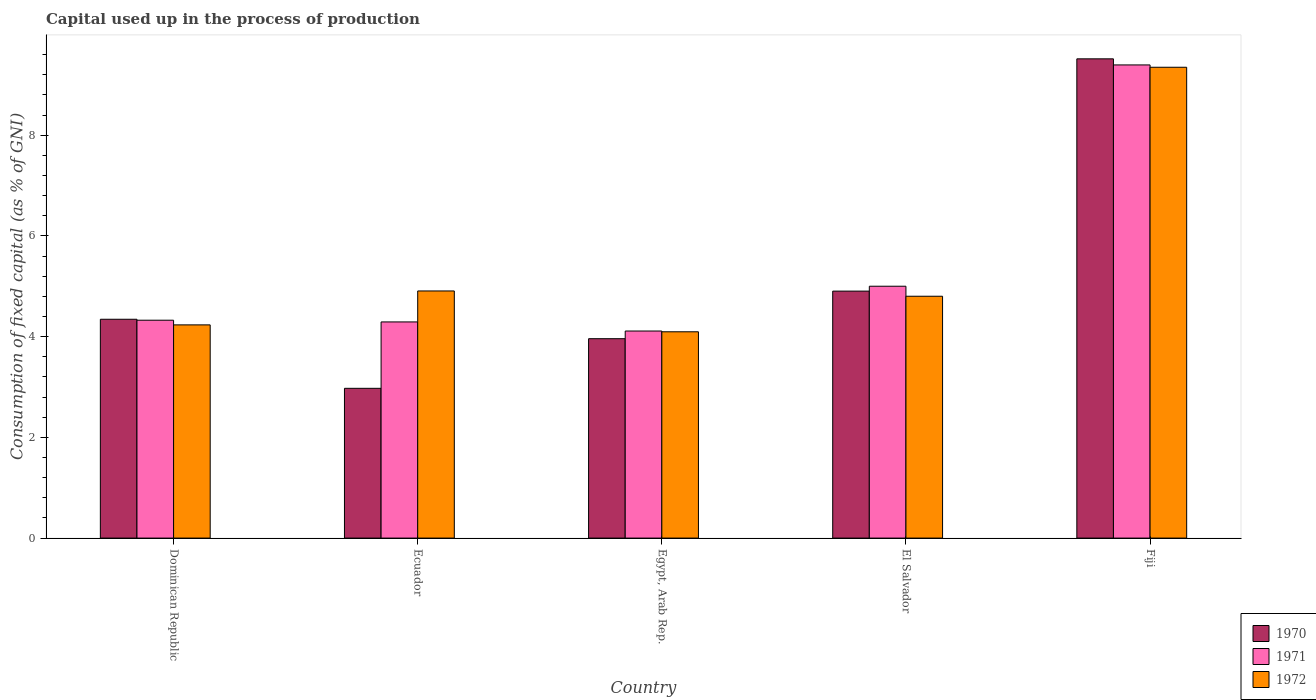How many different coloured bars are there?
Offer a very short reply. 3. How many groups of bars are there?
Give a very brief answer. 5. Are the number of bars per tick equal to the number of legend labels?
Keep it short and to the point. Yes. How many bars are there on the 1st tick from the left?
Provide a short and direct response. 3. How many bars are there on the 5th tick from the right?
Provide a succinct answer. 3. What is the label of the 2nd group of bars from the left?
Your answer should be very brief. Ecuador. In how many cases, is the number of bars for a given country not equal to the number of legend labels?
Your response must be concise. 0. What is the capital used up in the process of production in 1970 in Ecuador?
Your answer should be compact. 2.97. Across all countries, what is the maximum capital used up in the process of production in 1972?
Offer a very short reply. 9.35. Across all countries, what is the minimum capital used up in the process of production in 1970?
Offer a very short reply. 2.97. In which country was the capital used up in the process of production in 1971 maximum?
Provide a succinct answer. Fiji. In which country was the capital used up in the process of production in 1972 minimum?
Make the answer very short. Egypt, Arab Rep. What is the total capital used up in the process of production in 1972 in the graph?
Make the answer very short. 27.39. What is the difference between the capital used up in the process of production in 1972 in Ecuador and that in Fiji?
Your answer should be very brief. -4.44. What is the difference between the capital used up in the process of production in 1972 in Dominican Republic and the capital used up in the process of production in 1971 in Egypt, Arab Rep.?
Provide a short and direct response. 0.12. What is the average capital used up in the process of production in 1971 per country?
Your answer should be compact. 5.42. What is the difference between the capital used up in the process of production of/in 1972 and capital used up in the process of production of/in 1971 in Egypt, Arab Rep.?
Ensure brevity in your answer.  -0.02. In how many countries, is the capital used up in the process of production in 1970 greater than 5.6 %?
Ensure brevity in your answer.  1. What is the ratio of the capital used up in the process of production in 1970 in Egypt, Arab Rep. to that in Fiji?
Ensure brevity in your answer.  0.42. Is the capital used up in the process of production in 1971 in Ecuador less than that in El Salvador?
Your answer should be compact. Yes. What is the difference between the highest and the second highest capital used up in the process of production in 1972?
Your answer should be very brief. 4.44. What is the difference between the highest and the lowest capital used up in the process of production in 1971?
Ensure brevity in your answer.  5.28. Is the sum of the capital used up in the process of production in 1971 in Dominican Republic and Egypt, Arab Rep. greater than the maximum capital used up in the process of production in 1970 across all countries?
Give a very brief answer. No. What does the 2nd bar from the left in Egypt, Arab Rep. represents?
Provide a short and direct response. 1971. What does the 2nd bar from the right in Dominican Republic represents?
Give a very brief answer. 1971. Are all the bars in the graph horizontal?
Your answer should be very brief. No. What is the difference between two consecutive major ticks on the Y-axis?
Provide a succinct answer. 2. Does the graph contain any zero values?
Offer a terse response. No. Does the graph contain grids?
Your response must be concise. No. Where does the legend appear in the graph?
Provide a short and direct response. Bottom right. What is the title of the graph?
Offer a terse response. Capital used up in the process of production. What is the label or title of the X-axis?
Give a very brief answer. Country. What is the label or title of the Y-axis?
Give a very brief answer. Consumption of fixed capital (as % of GNI). What is the Consumption of fixed capital (as % of GNI) of 1970 in Dominican Republic?
Give a very brief answer. 4.34. What is the Consumption of fixed capital (as % of GNI) in 1971 in Dominican Republic?
Your response must be concise. 4.33. What is the Consumption of fixed capital (as % of GNI) of 1972 in Dominican Republic?
Provide a succinct answer. 4.23. What is the Consumption of fixed capital (as % of GNI) of 1970 in Ecuador?
Your answer should be very brief. 2.97. What is the Consumption of fixed capital (as % of GNI) in 1971 in Ecuador?
Make the answer very short. 4.29. What is the Consumption of fixed capital (as % of GNI) of 1972 in Ecuador?
Give a very brief answer. 4.91. What is the Consumption of fixed capital (as % of GNI) in 1970 in Egypt, Arab Rep.?
Give a very brief answer. 3.96. What is the Consumption of fixed capital (as % of GNI) of 1971 in Egypt, Arab Rep.?
Keep it short and to the point. 4.11. What is the Consumption of fixed capital (as % of GNI) of 1972 in Egypt, Arab Rep.?
Your answer should be compact. 4.1. What is the Consumption of fixed capital (as % of GNI) of 1970 in El Salvador?
Provide a short and direct response. 4.9. What is the Consumption of fixed capital (as % of GNI) of 1971 in El Salvador?
Offer a very short reply. 5. What is the Consumption of fixed capital (as % of GNI) in 1972 in El Salvador?
Offer a very short reply. 4.8. What is the Consumption of fixed capital (as % of GNI) of 1970 in Fiji?
Offer a very short reply. 9.52. What is the Consumption of fixed capital (as % of GNI) of 1971 in Fiji?
Offer a terse response. 9.39. What is the Consumption of fixed capital (as % of GNI) in 1972 in Fiji?
Offer a terse response. 9.35. Across all countries, what is the maximum Consumption of fixed capital (as % of GNI) of 1970?
Your answer should be compact. 9.52. Across all countries, what is the maximum Consumption of fixed capital (as % of GNI) in 1971?
Your answer should be very brief. 9.39. Across all countries, what is the maximum Consumption of fixed capital (as % of GNI) of 1972?
Offer a very short reply. 9.35. Across all countries, what is the minimum Consumption of fixed capital (as % of GNI) of 1970?
Your answer should be compact. 2.97. Across all countries, what is the minimum Consumption of fixed capital (as % of GNI) in 1971?
Offer a very short reply. 4.11. Across all countries, what is the minimum Consumption of fixed capital (as % of GNI) in 1972?
Make the answer very short. 4.1. What is the total Consumption of fixed capital (as % of GNI) in 1970 in the graph?
Keep it short and to the point. 25.7. What is the total Consumption of fixed capital (as % of GNI) in 1971 in the graph?
Offer a very short reply. 27.12. What is the total Consumption of fixed capital (as % of GNI) in 1972 in the graph?
Offer a very short reply. 27.39. What is the difference between the Consumption of fixed capital (as % of GNI) in 1970 in Dominican Republic and that in Ecuador?
Offer a very short reply. 1.37. What is the difference between the Consumption of fixed capital (as % of GNI) in 1971 in Dominican Republic and that in Ecuador?
Your answer should be compact. 0.03. What is the difference between the Consumption of fixed capital (as % of GNI) in 1972 in Dominican Republic and that in Ecuador?
Your answer should be compact. -0.67. What is the difference between the Consumption of fixed capital (as % of GNI) of 1970 in Dominican Republic and that in Egypt, Arab Rep.?
Ensure brevity in your answer.  0.39. What is the difference between the Consumption of fixed capital (as % of GNI) of 1971 in Dominican Republic and that in Egypt, Arab Rep.?
Make the answer very short. 0.21. What is the difference between the Consumption of fixed capital (as % of GNI) of 1972 in Dominican Republic and that in Egypt, Arab Rep.?
Make the answer very short. 0.14. What is the difference between the Consumption of fixed capital (as % of GNI) in 1970 in Dominican Republic and that in El Salvador?
Give a very brief answer. -0.56. What is the difference between the Consumption of fixed capital (as % of GNI) of 1971 in Dominican Republic and that in El Salvador?
Offer a terse response. -0.67. What is the difference between the Consumption of fixed capital (as % of GNI) in 1972 in Dominican Republic and that in El Salvador?
Keep it short and to the point. -0.57. What is the difference between the Consumption of fixed capital (as % of GNI) of 1970 in Dominican Republic and that in Fiji?
Keep it short and to the point. -5.17. What is the difference between the Consumption of fixed capital (as % of GNI) in 1971 in Dominican Republic and that in Fiji?
Give a very brief answer. -5.07. What is the difference between the Consumption of fixed capital (as % of GNI) in 1972 in Dominican Republic and that in Fiji?
Keep it short and to the point. -5.12. What is the difference between the Consumption of fixed capital (as % of GNI) of 1970 in Ecuador and that in Egypt, Arab Rep.?
Give a very brief answer. -0.99. What is the difference between the Consumption of fixed capital (as % of GNI) in 1971 in Ecuador and that in Egypt, Arab Rep.?
Your answer should be very brief. 0.18. What is the difference between the Consumption of fixed capital (as % of GNI) in 1972 in Ecuador and that in Egypt, Arab Rep.?
Provide a short and direct response. 0.81. What is the difference between the Consumption of fixed capital (as % of GNI) of 1970 in Ecuador and that in El Salvador?
Provide a succinct answer. -1.93. What is the difference between the Consumption of fixed capital (as % of GNI) in 1971 in Ecuador and that in El Salvador?
Give a very brief answer. -0.71. What is the difference between the Consumption of fixed capital (as % of GNI) of 1972 in Ecuador and that in El Salvador?
Keep it short and to the point. 0.1. What is the difference between the Consumption of fixed capital (as % of GNI) of 1970 in Ecuador and that in Fiji?
Make the answer very short. -6.54. What is the difference between the Consumption of fixed capital (as % of GNI) of 1971 in Ecuador and that in Fiji?
Your response must be concise. -5.1. What is the difference between the Consumption of fixed capital (as % of GNI) in 1972 in Ecuador and that in Fiji?
Your response must be concise. -4.44. What is the difference between the Consumption of fixed capital (as % of GNI) of 1970 in Egypt, Arab Rep. and that in El Salvador?
Keep it short and to the point. -0.94. What is the difference between the Consumption of fixed capital (as % of GNI) in 1971 in Egypt, Arab Rep. and that in El Salvador?
Ensure brevity in your answer.  -0.89. What is the difference between the Consumption of fixed capital (as % of GNI) of 1972 in Egypt, Arab Rep. and that in El Salvador?
Keep it short and to the point. -0.71. What is the difference between the Consumption of fixed capital (as % of GNI) in 1970 in Egypt, Arab Rep. and that in Fiji?
Your response must be concise. -5.56. What is the difference between the Consumption of fixed capital (as % of GNI) in 1971 in Egypt, Arab Rep. and that in Fiji?
Provide a succinct answer. -5.28. What is the difference between the Consumption of fixed capital (as % of GNI) of 1972 in Egypt, Arab Rep. and that in Fiji?
Make the answer very short. -5.25. What is the difference between the Consumption of fixed capital (as % of GNI) in 1970 in El Salvador and that in Fiji?
Give a very brief answer. -4.61. What is the difference between the Consumption of fixed capital (as % of GNI) of 1971 in El Salvador and that in Fiji?
Your answer should be very brief. -4.39. What is the difference between the Consumption of fixed capital (as % of GNI) in 1972 in El Salvador and that in Fiji?
Your response must be concise. -4.55. What is the difference between the Consumption of fixed capital (as % of GNI) of 1970 in Dominican Republic and the Consumption of fixed capital (as % of GNI) of 1971 in Ecuador?
Your response must be concise. 0.05. What is the difference between the Consumption of fixed capital (as % of GNI) of 1970 in Dominican Republic and the Consumption of fixed capital (as % of GNI) of 1972 in Ecuador?
Provide a succinct answer. -0.56. What is the difference between the Consumption of fixed capital (as % of GNI) in 1971 in Dominican Republic and the Consumption of fixed capital (as % of GNI) in 1972 in Ecuador?
Make the answer very short. -0.58. What is the difference between the Consumption of fixed capital (as % of GNI) in 1970 in Dominican Republic and the Consumption of fixed capital (as % of GNI) in 1971 in Egypt, Arab Rep.?
Your response must be concise. 0.23. What is the difference between the Consumption of fixed capital (as % of GNI) in 1970 in Dominican Republic and the Consumption of fixed capital (as % of GNI) in 1972 in Egypt, Arab Rep.?
Offer a terse response. 0.25. What is the difference between the Consumption of fixed capital (as % of GNI) of 1971 in Dominican Republic and the Consumption of fixed capital (as % of GNI) of 1972 in Egypt, Arab Rep.?
Ensure brevity in your answer.  0.23. What is the difference between the Consumption of fixed capital (as % of GNI) of 1970 in Dominican Republic and the Consumption of fixed capital (as % of GNI) of 1971 in El Salvador?
Keep it short and to the point. -0.66. What is the difference between the Consumption of fixed capital (as % of GNI) of 1970 in Dominican Republic and the Consumption of fixed capital (as % of GNI) of 1972 in El Salvador?
Ensure brevity in your answer.  -0.46. What is the difference between the Consumption of fixed capital (as % of GNI) in 1971 in Dominican Republic and the Consumption of fixed capital (as % of GNI) in 1972 in El Salvador?
Provide a short and direct response. -0.48. What is the difference between the Consumption of fixed capital (as % of GNI) of 1970 in Dominican Republic and the Consumption of fixed capital (as % of GNI) of 1971 in Fiji?
Give a very brief answer. -5.05. What is the difference between the Consumption of fixed capital (as % of GNI) in 1970 in Dominican Republic and the Consumption of fixed capital (as % of GNI) in 1972 in Fiji?
Keep it short and to the point. -5. What is the difference between the Consumption of fixed capital (as % of GNI) of 1971 in Dominican Republic and the Consumption of fixed capital (as % of GNI) of 1972 in Fiji?
Keep it short and to the point. -5.02. What is the difference between the Consumption of fixed capital (as % of GNI) of 1970 in Ecuador and the Consumption of fixed capital (as % of GNI) of 1971 in Egypt, Arab Rep.?
Make the answer very short. -1.14. What is the difference between the Consumption of fixed capital (as % of GNI) in 1970 in Ecuador and the Consumption of fixed capital (as % of GNI) in 1972 in Egypt, Arab Rep.?
Give a very brief answer. -1.12. What is the difference between the Consumption of fixed capital (as % of GNI) of 1971 in Ecuador and the Consumption of fixed capital (as % of GNI) of 1972 in Egypt, Arab Rep.?
Provide a short and direct response. 0.2. What is the difference between the Consumption of fixed capital (as % of GNI) of 1970 in Ecuador and the Consumption of fixed capital (as % of GNI) of 1971 in El Salvador?
Your response must be concise. -2.03. What is the difference between the Consumption of fixed capital (as % of GNI) of 1970 in Ecuador and the Consumption of fixed capital (as % of GNI) of 1972 in El Salvador?
Ensure brevity in your answer.  -1.83. What is the difference between the Consumption of fixed capital (as % of GNI) of 1971 in Ecuador and the Consumption of fixed capital (as % of GNI) of 1972 in El Salvador?
Your response must be concise. -0.51. What is the difference between the Consumption of fixed capital (as % of GNI) of 1970 in Ecuador and the Consumption of fixed capital (as % of GNI) of 1971 in Fiji?
Keep it short and to the point. -6.42. What is the difference between the Consumption of fixed capital (as % of GNI) of 1970 in Ecuador and the Consumption of fixed capital (as % of GNI) of 1972 in Fiji?
Provide a short and direct response. -6.37. What is the difference between the Consumption of fixed capital (as % of GNI) in 1971 in Ecuador and the Consumption of fixed capital (as % of GNI) in 1972 in Fiji?
Offer a very short reply. -5.06. What is the difference between the Consumption of fixed capital (as % of GNI) in 1970 in Egypt, Arab Rep. and the Consumption of fixed capital (as % of GNI) in 1971 in El Salvador?
Your response must be concise. -1.04. What is the difference between the Consumption of fixed capital (as % of GNI) in 1970 in Egypt, Arab Rep. and the Consumption of fixed capital (as % of GNI) in 1972 in El Salvador?
Offer a terse response. -0.84. What is the difference between the Consumption of fixed capital (as % of GNI) in 1971 in Egypt, Arab Rep. and the Consumption of fixed capital (as % of GNI) in 1972 in El Salvador?
Offer a terse response. -0.69. What is the difference between the Consumption of fixed capital (as % of GNI) of 1970 in Egypt, Arab Rep. and the Consumption of fixed capital (as % of GNI) of 1971 in Fiji?
Offer a terse response. -5.44. What is the difference between the Consumption of fixed capital (as % of GNI) in 1970 in Egypt, Arab Rep. and the Consumption of fixed capital (as % of GNI) in 1972 in Fiji?
Your answer should be very brief. -5.39. What is the difference between the Consumption of fixed capital (as % of GNI) of 1971 in Egypt, Arab Rep. and the Consumption of fixed capital (as % of GNI) of 1972 in Fiji?
Provide a succinct answer. -5.24. What is the difference between the Consumption of fixed capital (as % of GNI) in 1970 in El Salvador and the Consumption of fixed capital (as % of GNI) in 1971 in Fiji?
Offer a terse response. -4.49. What is the difference between the Consumption of fixed capital (as % of GNI) in 1970 in El Salvador and the Consumption of fixed capital (as % of GNI) in 1972 in Fiji?
Provide a short and direct response. -4.44. What is the difference between the Consumption of fixed capital (as % of GNI) of 1971 in El Salvador and the Consumption of fixed capital (as % of GNI) of 1972 in Fiji?
Provide a succinct answer. -4.35. What is the average Consumption of fixed capital (as % of GNI) of 1970 per country?
Offer a very short reply. 5.14. What is the average Consumption of fixed capital (as % of GNI) in 1971 per country?
Offer a terse response. 5.42. What is the average Consumption of fixed capital (as % of GNI) in 1972 per country?
Your response must be concise. 5.48. What is the difference between the Consumption of fixed capital (as % of GNI) of 1970 and Consumption of fixed capital (as % of GNI) of 1971 in Dominican Republic?
Keep it short and to the point. 0.02. What is the difference between the Consumption of fixed capital (as % of GNI) of 1970 and Consumption of fixed capital (as % of GNI) of 1972 in Dominican Republic?
Offer a terse response. 0.11. What is the difference between the Consumption of fixed capital (as % of GNI) of 1971 and Consumption of fixed capital (as % of GNI) of 1972 in Dominican Republic?
Offer a terse response. 0.09. What is the difference between the Consumption of fixed capital (as % of GNI) in 1970 and Consumption of fixed capital (as % of GNI) in 1971 in Ecuador?
Your response must be concise. -1.32. What is the difference between the Consumption of fixed capital (as % of GNI) in 1970 and Consumption of fixed capital (as % of GNI) in 1972 in Ecuador?
Provide a succinct answer. -1.93. What is the difference between the Consumption of fixed capital (as % of GNI) in 1971 and Consumption of fixed capital (as % of GNI) in 1972 in Ecuador?
Your answer should be very brief. -0.61. What is the difference between the Consumption of fixed capital (as % of GNI) of 1970 and Consumption of fixed capital (as % of GNI) of 1971 in Egypt, Arab Rep.?
Provide a short and direct response. -0.15. What is the difference between the Consumption of fixed capital (as % of GNI) of 1970 and Consumption of fixed capital (as % of GNI) of 1972 in Egypt, Arab Rep.?
Provide a succinct answer. -0.14. What is the difference between the Consumption of fixed capital (as % of GNI) in 1971 and Consumption of fixed capital (as % of GNI) in 1972 in Egypt, Arab Rep.?
Offer a terse response. 0.02. What is the difference between the Consumption of fixed capital (as % of GNI) of 1970 and Consumption of fixed capital (as % of GNI) of 1971 in El Salvador?
Provide a short and direct response. -0.1. What is the difference between the Consumption of fixed capital (as % of GNI) in 1970 and Consumption of fixed capital (as % of GNI) in 1972 in El Salvador?
Your answer should be compact. 0.1. What is the difference between the Consumption of fixed capital (as % of GNI) of 1971 and Consumption of fixed capital (as % of GNI) of 1972 in El Salvador?
Give a very brief answer. 0.2. What is the difference between the Consumption of fixed capital (as % of GNI) in 1970 and Consumption of fixed capital (as % of GNI) in 1971 in Fiji?
Keep it short and to the point. 0.12. What is the difference between the Consumption of fixed capital (as % of GNI) of 1970 and Consumption of fixed capital (as % of GNI) of 1972 in Fiji?
Provide a succinct answer. 0.17. What is the difference between the Consumption of fixed capital (as % of GNI) of 1971 and Consumption of fixed capital (as % of GNI) of 1972 in Fiji?
Give a very brief answer. 0.05. What is the ratio of the Consumption of fixed capital (as % of GNI) of 1970 in Dominican Republic to that in Ecuador?
Your answer should be very brief. 1.46. What is the ratio of the Consumption of fixed capital (as % of GNI) in 1971 in Dominican Republic to that in Ecuador?
Offer a terse response. 1.01. What is the ratio of the Consumption of fixed capital (as % of GNI) of 1972 in Dominican Republic to that in Ecuador?
Ensure brevity in your answer.  0.86. What is the ratio of the Consumption of fixed capital (as % of GNI) of 1970 in Dominican Republic to that in Egypt, Arab Rep.?
Give a very brief answer. 1.1. What is the ratio of the Consumption of fixed capital (as % of GNI) of 1971 in Dominican Republic to that in Egypt, Arab Rep.?
Offer a very short reply. 1.05. What is the ratio of the Consumption of fixed capital (as % of GNI) in 1972 in Dominican Republic to that in Egypt, Arab Rep.?
Your answer should be very brief. 1.03. What is the ratio of the Consumption of fixed capital (as % of GNI) in 1970 in Dominican Republic to that in El Salvador?
Your answer should be compact. 0.89. What is the ratio of the Consumption of fixed capital (as % of GNI) of 1971 in Dominican Republic to that in El Salvador?
Your answer should be very brief. 0.87. What is the ratio of the Consumption of fixed capital (as % of GNI) in 1972 in Dominican Republic to that in El Salvador?
Your response must be concise. 0.88. What is the ratio of the Consumption of fixed capital (as % of GNI) of 1970 in Dominican Republic to that in Fiji?
Offer a terse response. 0.46. What is the ratio of the Consumption of fixed capital (as % of GNI) in 1971 in Dominican Republic to that in Fiji?
Give a very brief answer. 0.46. What is the ratio of the Consumption of fixed capital (as % of GNI) in 1972 in Dominican Republic to that in Fiji?
Offer a very short reply. 0.45. What is the ratio of the Consumption of fixed capital (as % of GNI) in 1970 in Ecuador to that in Egypt, Arab Rep.?
Your answer should be compact. 0.75. What is the ratio of the Consumption of fixed capital (as % of GNI) of 1971 in Ecuador to that in Egypt, Arab Rep.?
Your answer should be very brief. 1.04. What is the ratio of the Consumption of fixed capital (as % of GNI) in 1972 in Ecuador to that in Egypt, Arab Rep.?
Keep it short and to the point. 1.2. What is the ratio of the Consumption of fixed capital (as % of GNI) in 1970 in Ecuador to that in El Salvador?
Ensure brevity in your answer.  0.61. What is the ratio of the Consumption of fixed capital (as % of GNI) in 1971 in Ecuador to that in El Salvador?
Offer a terse response. 0.86. What is the ratio of the Consumption of fixed capital (as % of GNI) in 1972 in Ecuador to that in El Salvador?
Give a very brief answer. 1.02. What is the ratio of the Consumption of fixed capital (as % of GNI) of 1970 in Ecuador to that in Fiji?
Your answer should be compact. 0.31. What is the ratio of the Consumption of fixed capital (as % of GNI) in 1971 in Ecuador to that in Fiji?
Offer a terse response. 0.46. What is the ratio of the Consumption of fixed capital (as % of GNI) of 1972 in Ecuador to that in Fiji?
Provide a short and direct response. 0.52. What is the ratio of the Consumption of fixed capital (as % of GNI) in 1970 in Egypt, Arab Rep. to that in El Salvador?
Give a very brief answer. 0.81. What is the ratio of the Consumption of fixed capital (as % of GNI) in 1971 in Egypt, Arab Rep. to that in El Salvador?
Your answer should be very brief. 0.82. What is the ratio of the Consumption of fixed capital (as % of GNI) in 1972 in Egypt, Arab Rep. to that in El Salvador?
Your response must be concise. 0.85. What is the ratio of the Consumption of fixed capital (as % of GNI) of 1970 in Egypt, Arab Rep. to that in Fiji?
Ensure brevity in your answer.  0.42. What is the ratio of the Consumption of fixed capital (as % of GNI) in 1971 in Egypt, Arab Rep. to that in Fiji?
Give a very brief answer. 0.44. What is the ratio of the Consumption of fixed capital (as % of GNI) of 1972 in Egypt, Arab Rep. to that in Fiji?
Your answer should be compact. 0.44. What is the ratio of the Consumption of fixed capital (as % of GNI) in 1970 in El Salvador to that in Fiji?
Keep it short and to the point. 0.52. What is the ratio of the Consumption of fixed capital (as % of GNI) of 1971 in El Salvador to that in Fiji?
Your response must be concise. 0.53. What is the ratio of the Consumption of fixed capital (as % of GNI) in 1972 in El Salvador to that in Fiji?
Offer a very short reply. 0.51. What is the difference between the highest and the second highest Consumption of fixed capital (as % of GNI) in 1970?
Make the answer very short. 4.61. What is the difference between the highest and the second highest Consumption of fixed capital (as % of GNI) of 1971?
Make the answer very short. 4.39. What is the difference between the highest and the second highest Consumption of fixed capital (as % of GNI) of 1972?
Keep it short and to the point. 4.44. What is the difference between the highest and the lowest Consumption of fixed capital (as % of GNI) in 1970?
Offer a very short reply. 6.54. What is the difference between the highest and the lowest Consumption of fixed capital (as % of GNI) of 1971?
Keep it short and to the point. 5.28. What is the difference between the highest and the lowest Consumption of fixed capital (as % of GNI) of 1972?
Provide a short and direct response. 5.25. 